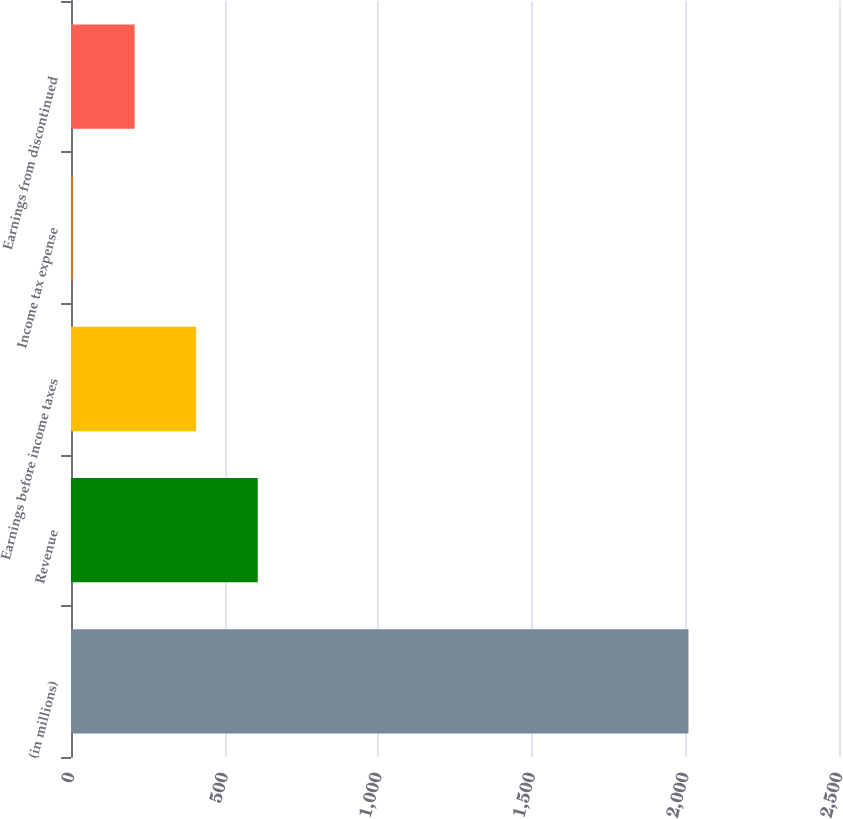Convert chart to OTSL. <chart><loc_0><loc_0><loc_500><loc_500><bar_chart><fcel>(in millions)<fcel>Revenue<fcel>Earnings before income taxes<fcel>Income tax expense<fcel>Earnings from discontinued<nl><fcel>2010<fcel>607.76<fcel>407.44<fcel>6.8<fcel>207.12<nl></chart> 